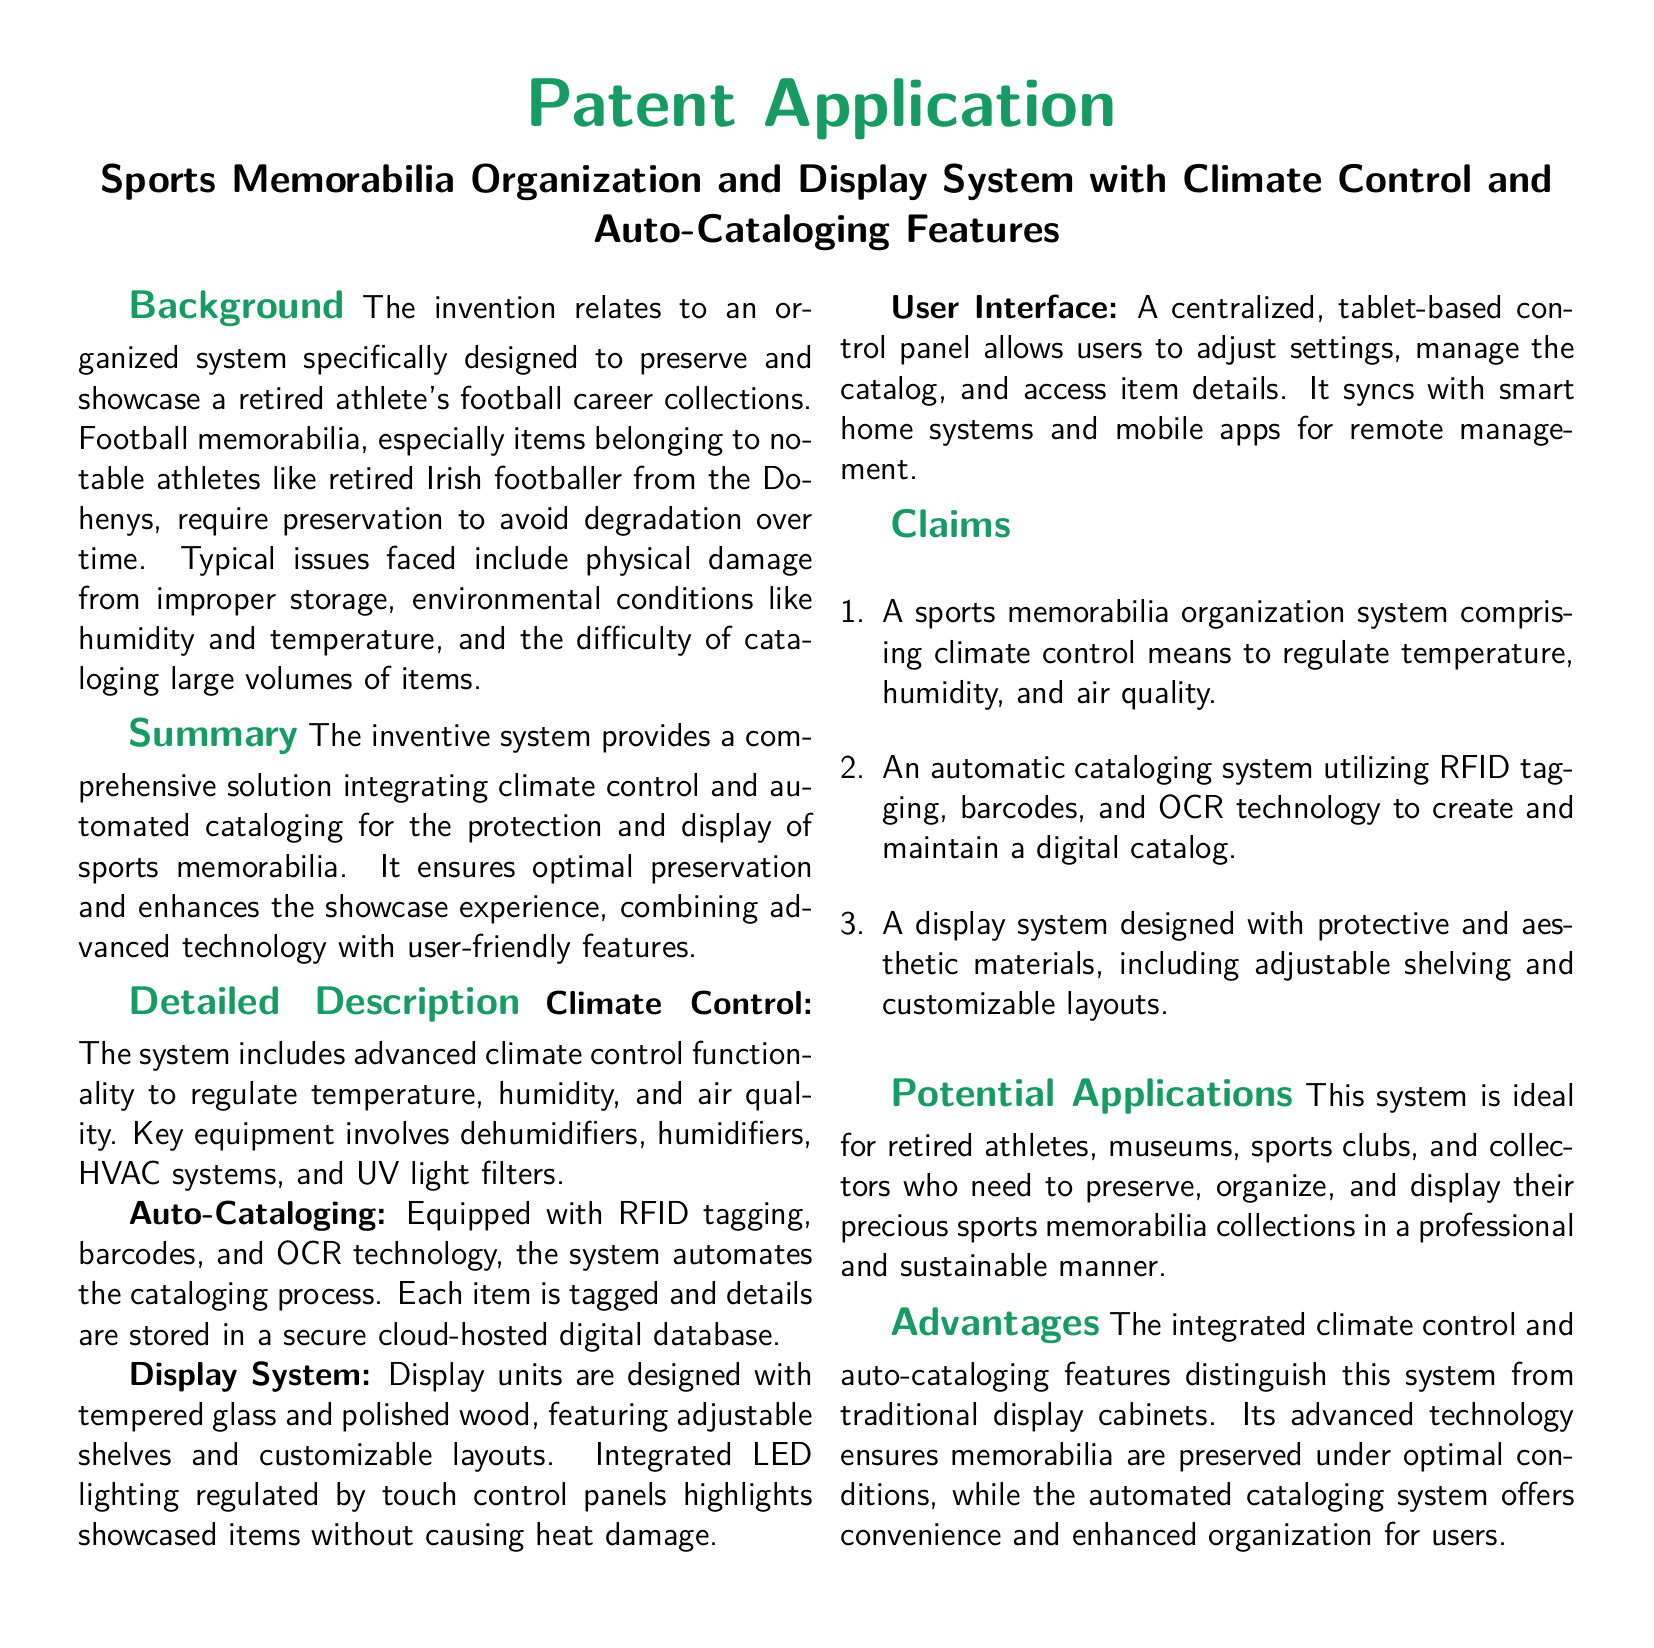what is the title of the patent application? The title is provided at the beginning of the document, summarizing its content.
Answer: Sports Memorabilia Organization and Display System with Climate Control and Auto-Cataloging Features what technology is used for auto-cataloging? The document mentions specific technologies employed for automating the cataloging process.
Answer: RFID tagging, barcodes, and OCR technology which materials are used in the display system? The document describes the materials used in the construction of the display units.
Answer: Tempered glass and polished wood what is the main purpose of the designed system? The purpose is outlined in the Summary section of the document.
Answer: Preserve and showcase sports memorabilia how many claims are listed in the document? The number of claims is indicated in the Claims section.
Answer: Three what user interface is utilized for the system? The document specifies the type of control panel employed for the user interface.
Answer: Tablet-based control panel what advantage does this system offer over traditional display cabinets? The Advantages section highlights unique features that set this system apart.
Answer: Integrated climate control and auto-cataloging features who is the target audience for this system? The document mentions potential users in the Potential Applications section.
Answer: Retired athletes, museums, sports clubs, and collectors 